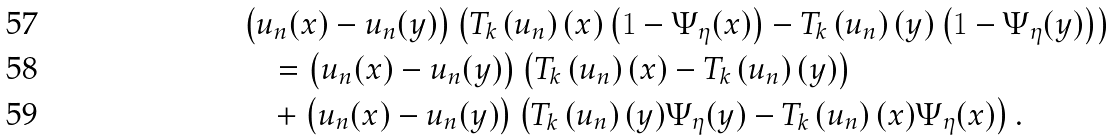<formula> <loc_0><loc_0><loc_500><loc_500>& \left ( u _ { n } ( x ) - u _ { n } ( y ) \right ) \left ( T _ { k } \left ( u _ { n } \right ) ( x ) \left ( 1 - \Psi _ { \eta } ( x ) \right ) - T _ { k } \left ( u _ { n } \right ) ( y ) \left ( 1 - \Psi _ { \eta } ( y ) \right ) \right ) \\ & \quad = \left ( u _ { n } ( x ) - u _ { n } ( y ) \right ) \left ( T _ { k } \left ( u _ { n } \right ) ( x ) - T _ { k } \left ( u _ { n } \right ) ( y ) \right ) \\ & \quad + \left ( u _ { n } ( x ) - u _ { n } ( y ) \right ) \left ( T _ { k } \left ( u _ { n } \right ) ( y ) \Psi _ { \eta } ( y ) - T _ { k } \left ( u _ { n } \right ) ( x ) \Psi _ { \eta } ( x ) \right ) .</formula> 